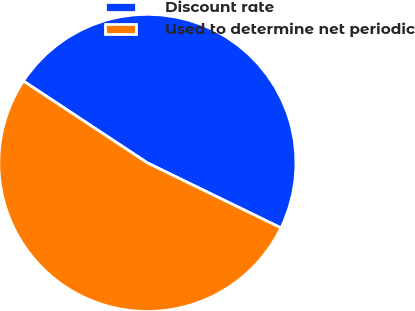Convert chart to OTSL. <chart><loc_0><loc_0><loc_500><loc_500><pie_chart><fcel>Discount rate<fcel>Used to determine net periodic<nl><fcel>47.92%<fcel>52.08%<nl></chart> 